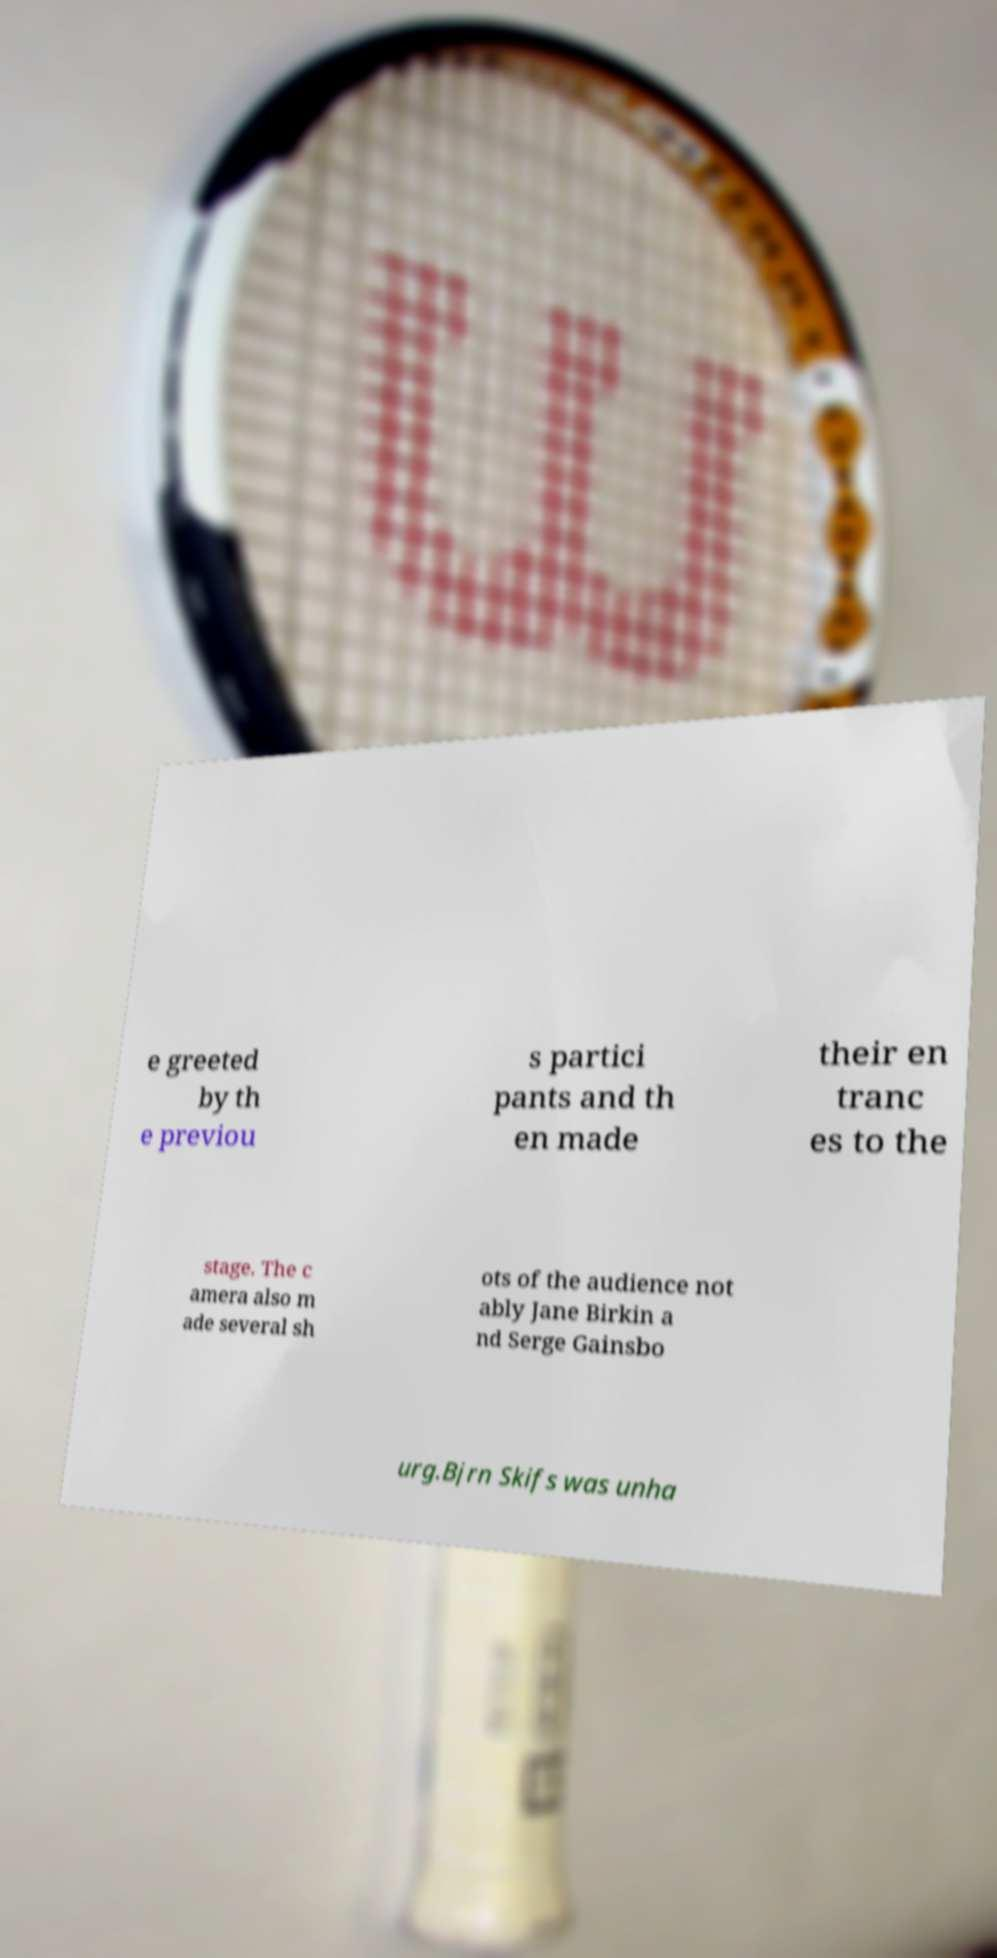I need the written content from this picture converted into text. Can you do that? e greeted by th e previou s partici pants and th en made their en tranc es to the stage. The c amera also m ade several sh ots of the audience not ably Jane Birkin a nd Serge Gainsbo urg.Bjrn Skifs was unha 